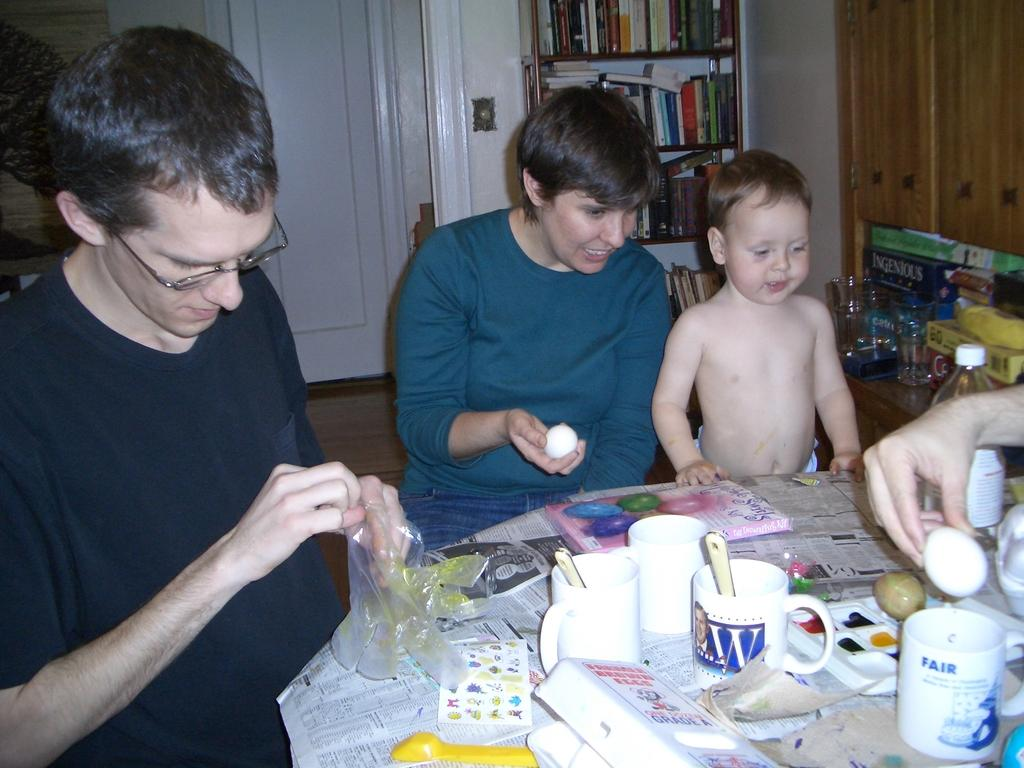How many people are in the image? There is a group of people in the image, but the exact number is not specified. What is placed in front of the group? There are glasses and papers in front of the group, as well as other objects. What can be seen in the background of the image? There are books in the background of the image, and the door is white. What type of instrument is being played by the group in the image? There is no instrument visible in the image, and no indication that the group members are playing any instruments. 